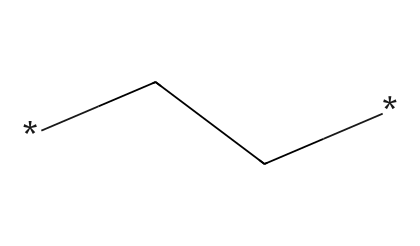What is the number of carbon atoms in polyethylene? The SMILES representation "CC" indicates two carbon atoms are connected in a chain. There are no additional carbon atoms in the structure.
Answer: two What type of bonding is present between the atoms in polyethylene? The structure shows that the carbon atoms are connected by single bonds (indicated by the absence of symbols like '=' or '≡' for double or triple bonds). Thus, the bonding is covalent.
Answer: covalent What is the general classification of polyethylene as a chemical compound? Polyethylene is classified as an aliphatic hydrocarbon because it consists only of carbon and hydrogen arranged in an open chain structure.
Answer: aliphatic hydrocarbon How many hydrogen atoms are in a molecule of polyethylene represented by "CC"? Each carbon atom in an alkane typically bonds with sufficient hydrogen atoms to fulfill the tetravalence of carbon. In this case, there are six hydrogen atoms in total (three from each terminal carbon and one from each internal carbon).
Answer: six What is the simplest repeating unit in polyethylene's polymer chain? The repeating unit in polyethylene is "C2H4," as it consists of two carbon atoms and four hydrogen atoms, characteristic of the alkene ethylene contributed by the polymerization.
Answer: C2H4 What property is indicated by the lack of functional groups in polyethylene? The absence of functional groups in the structure indicates that polyethylene is non-polar and hydrophobic, which contributes to its properties as an insulator in electrical applications.
Answer: non-polar 